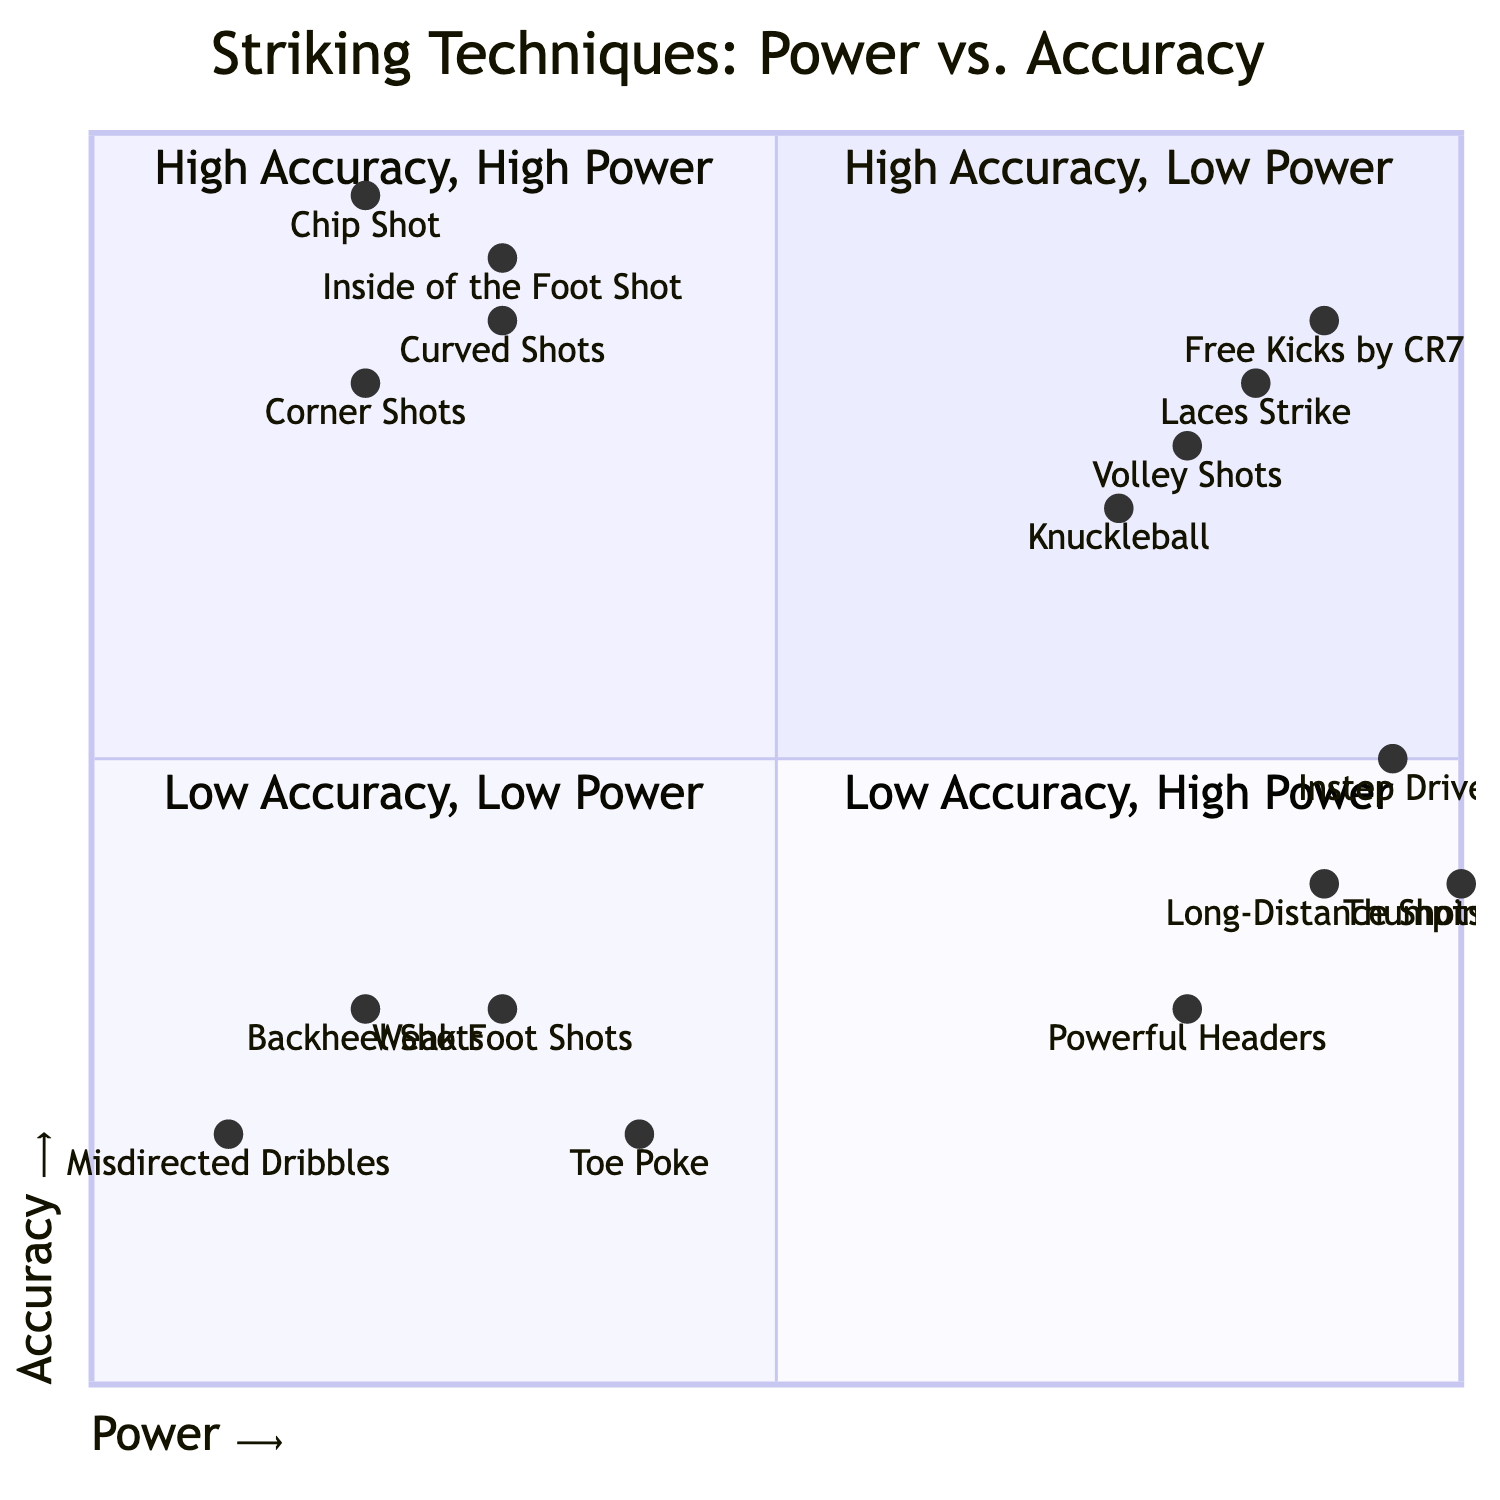What techniques are found in the High Accuracy, Low Power quadrant? The techniques listed in the High Accuracy, Low Power quadrant are "Inside of the Foot Shot" and "Chip Shot". These techniques focus on precision and control rather than force.
Answer: Inside of the Foot Shot, Chip Shot What examples fall under Low Accuracy, High Power? The examples in the Low Accuracy, High Power quadrant include "Long-Distance Shots" and "Powerful Headers". These shots emphasize strength, sometimes at the expense of precision.
Answer: Long-Distance Shots, Powerful Headers Which technique combines High Accuracy with High Power? The techniques that combine High Accuracy with High Power in the diagram are "Free Kicks by Cristiano Ronaldo" and "Volley Shots". These techniques achieve a balance of both power and precision.
Answer: Free Kicks by Cristiano Ronaldo, Volley Shots What is a key tip for Low Accuracy, Low Power techniques? A key tip for those utilizing Low Accuracy, Low Power techniques is to "work on basic ball handling and control first". This foundational skill is essential before advancing to more complex shots.
Answer: Work on basic ball handling and control first Which category does the "Knuckleball" shot belong to? The "Knuckleball" shot is categorized under High Accuracy, High Power, as it requires both precision and power to achieve its intended effect during play.
Answer: High Accuracy, High Power How many techniques are present in the Low Accuracy, Low Power quadrant? There are two techniques listed in the Low Accuracy, Low Power quadrant: "Toe Poke" and "Weak Foot Shots". This represents a basic level of striking skill with minimal force.
Answer: 2 What should be practiced for High Accuracy, High Power techniques? For High Accuracy, High Power techniques, one should "master proper body posture and follow through". This is crucial for maximizing both the accuracy and power of the shot.
Answer: Master proper body posture and follow through Which quadrant contains the most powerful examples? The quadrant that contains the most powerful examples is Low Accuracy, High Power, which includes examples like "Long-Distance Shots" and "Powerful Headers." These shots are characterized by their strength, albeit with lower precision.
Answer: Low Accuracy, High Power 